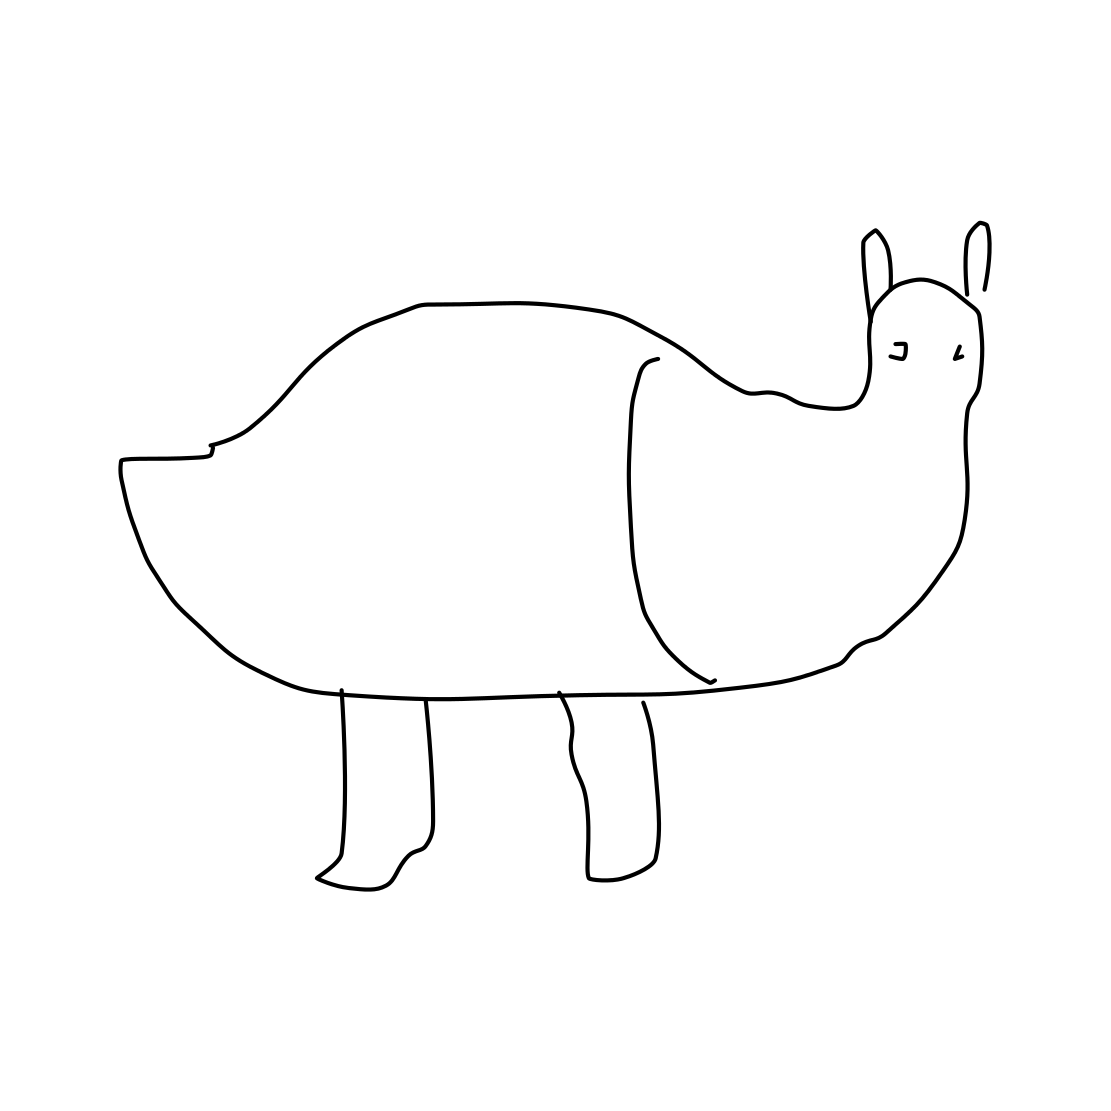If this image were to be the beginning of a children's book, what could the story be about? The story could be about an imaginative creature from a land of dreams and whimsy. The protagonist, depicted in the image, could embark on an adventure to find its place in a world where every creature is uniquely designed. Along the way, it meets various other fantastical animals, learning about diversity and the importance of self-acceptance. 